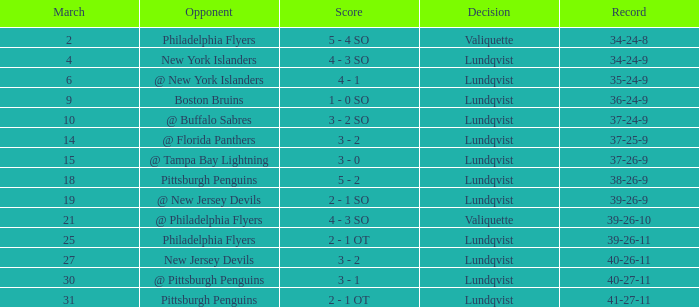Which score's game was less than 69 when the march was bigger than 2 and the opponents were the New York Islanders? 4 - 3 SO. 